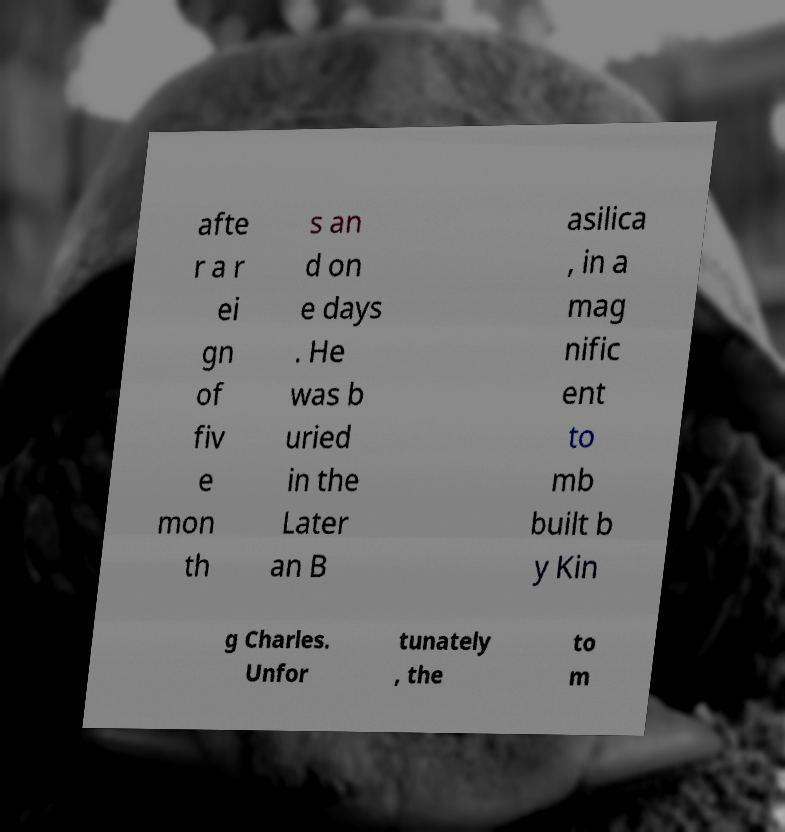Can you read and provide the text displayed in the image?This photo seems to have some interesting text. Can you extract and type it out for me? afte r a r ei gn of fiv e mon th s an d on e days . He was b uried in the Later an B asilica , in a mag nific ent to mb built b y Kin g Charles. Unfor tunately , the to m 